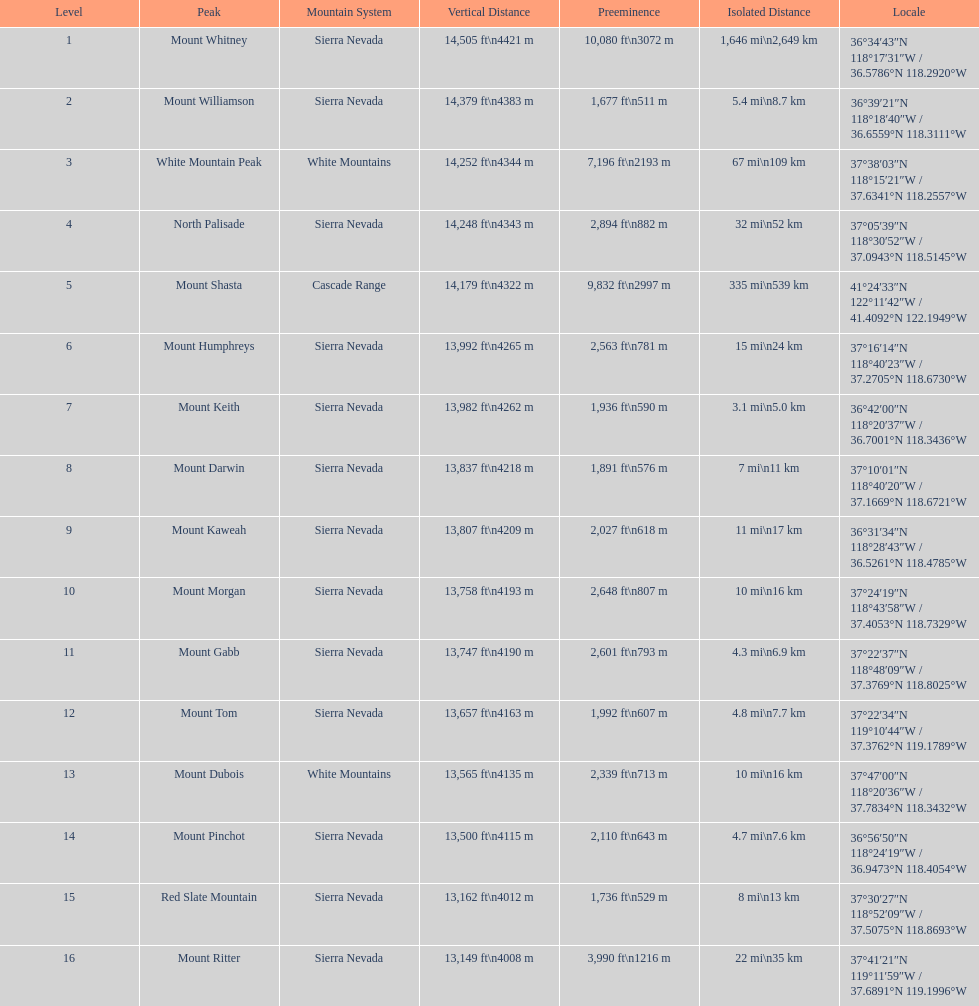What is the difference in height between the peaks of mount williamson and mount keith? 397 ft. 